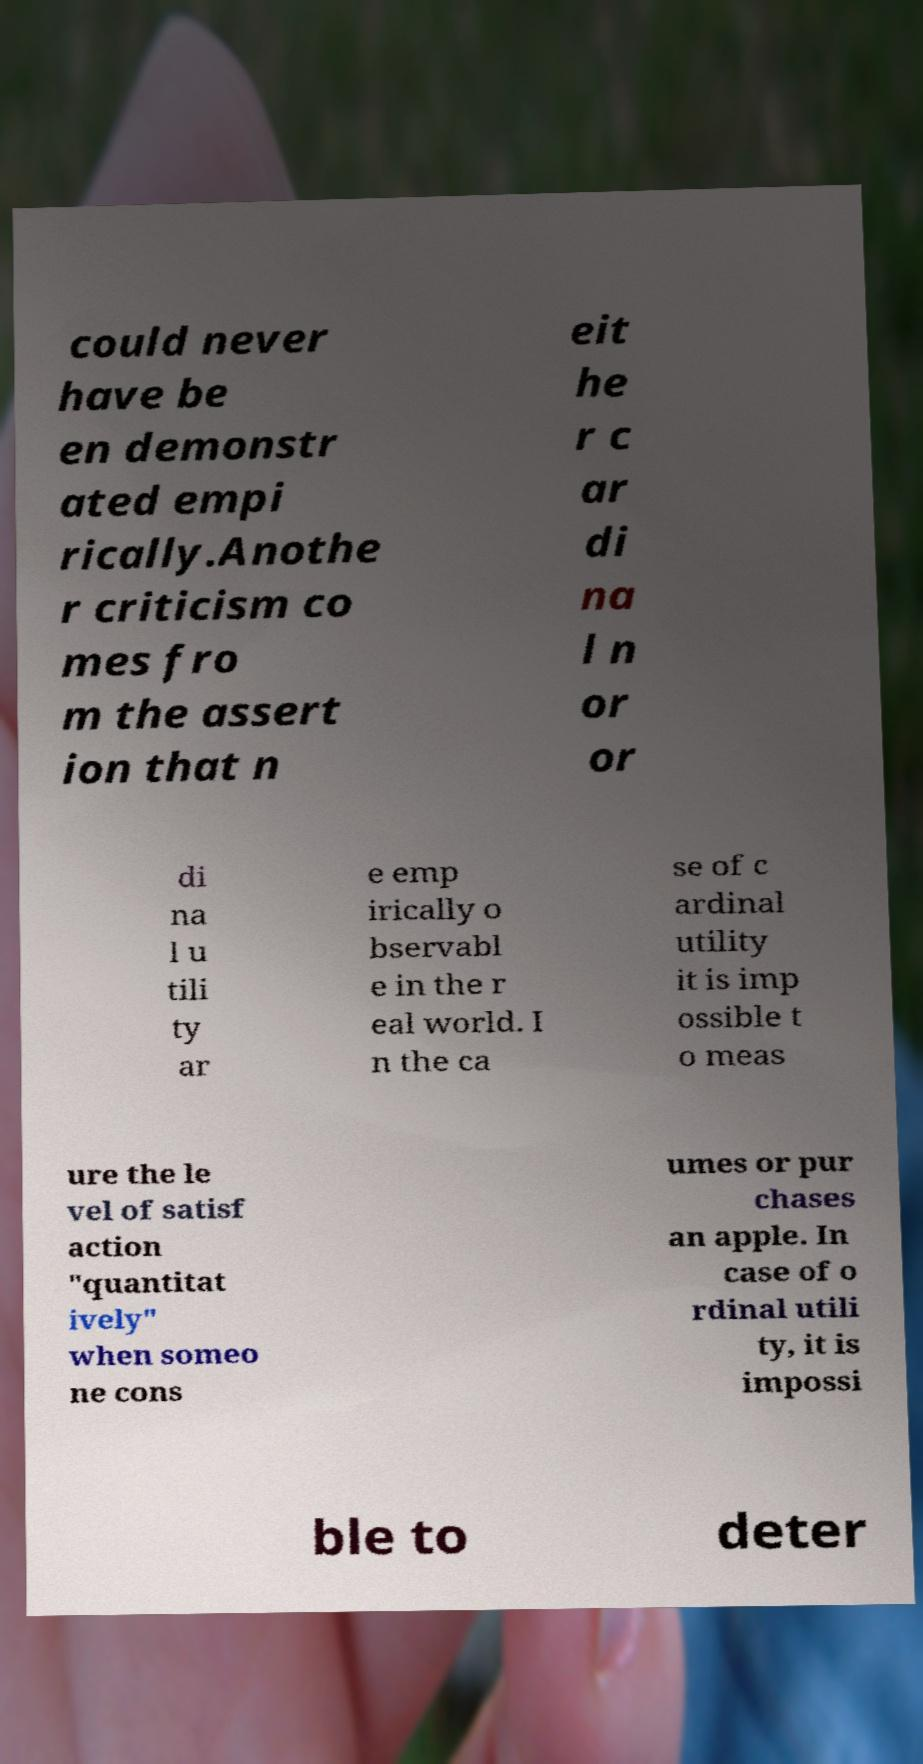What messages or text are displayed in this image? I need them in a readable, typed format. could never have be en demonstr ated empi rically.Anothe r criticism co mes fro m the assert ion that n eit he r c ar di na l n or or di na l u tili ty ar e emp irically o bservabl e in the r eal world. I n the ca se of c ardinal utility it is imp ossible t o meas ure the le vel of satisf action "quantitat ively" when someo ne cons umes or pur chases an apple. In case of o rdinal utili ty, it is impossi ble to deter 